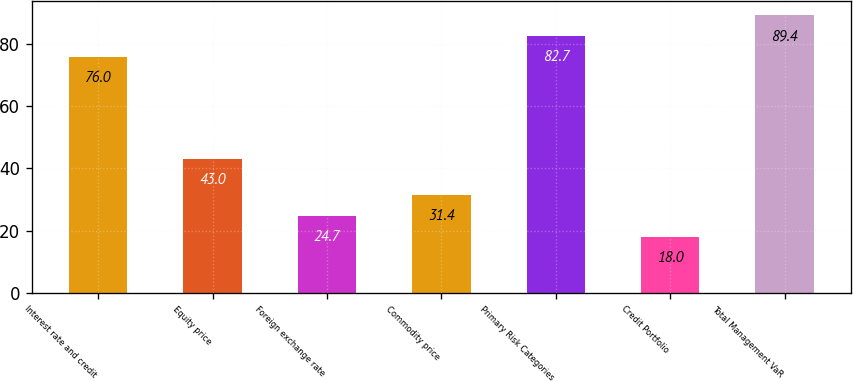<chart> <loc_0><loc_0><loc_500><loc_500><bar_chart><fcel>Interest rate and credit<fcel>Equity price<fcel>Foreign exchange rate<fcel>Commodity price<fcel>Primary Risk Categories<fcel>Credit Portfolio<fcel>Total Management VaR<nl><fcel>76<fcel>43<fcel>24.7<fcel>31.4<fcel>82.7<fcel>18<fcel>89.4<nl></chart> 